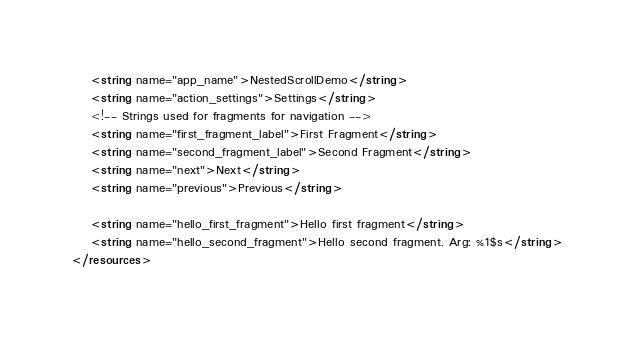<code> <loc_0><loc_0><loc_500><loc_500><_XML_>    <string name="app_name">NestedScrollDemo</string>
    <string name="action_settings">Settings</string>
    <!-- Strings used for fragments for navigation -->
    <string name="first_fragment_label">First Fragment</string>
    <string name="second_fragment_label">Second Fragment</string>
    <string name="next">Next</string>
    <string name="previous">Previous</string>

    <string name="hello_first_fragment">Hello first fragment</string>
    <string name="hello_second_fragment">Hello second fragment. Arg: %1$s</string>
</resources></code> 